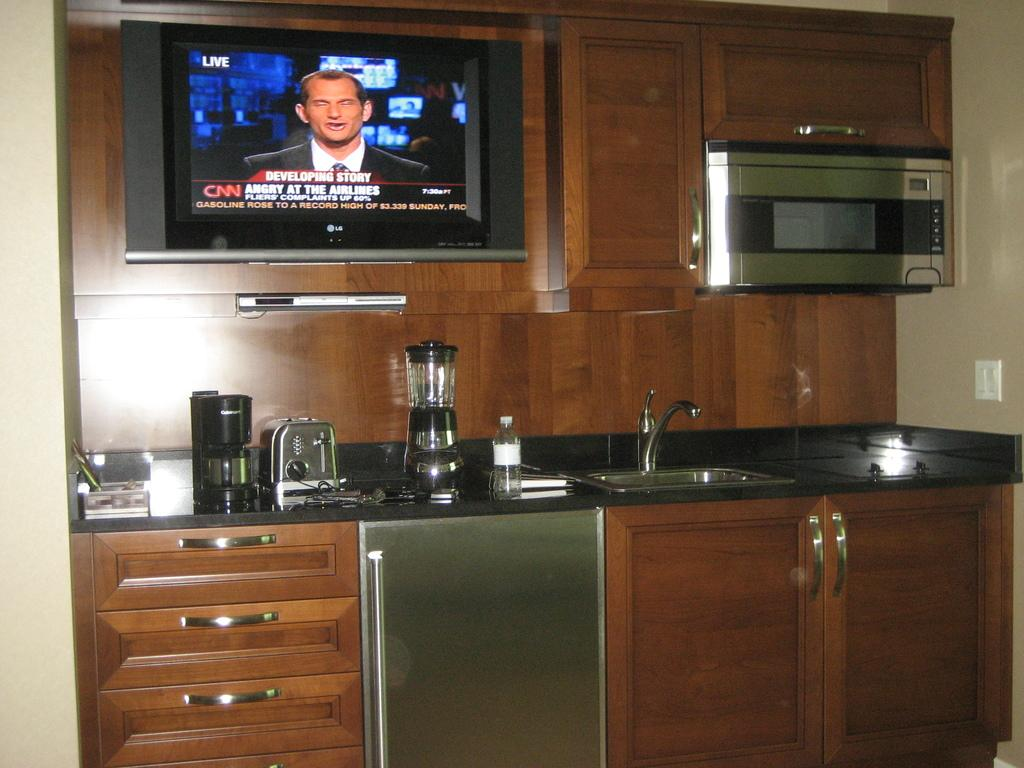Provide a one-sentence caption for the provided image. A modern counter top with a TV displaying live footage from CNN. 